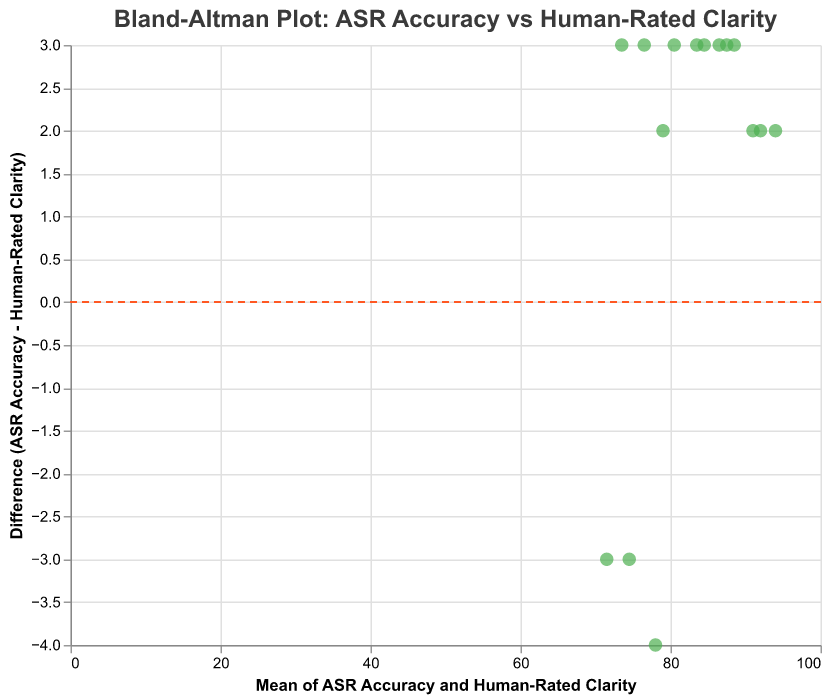What is the title of the plot? The title is typically located at the top of the plot and provides a concise description of what the figure represents. In this case, it gives an overview of the data being compared and the context.
Answer: Bland-Altman Plot: ASR Accuracy vs Human-Rated Clarity How many data points are plotted in the graph? The total number of data points can be counted by identifying each individual point on the plot. Each point corresponds to a specific app in the dataset.
Answer: 15 What does the horizontal axis represent? The horizontal axis is labeled with its respective description. It typically represents one of the variables being compared or a transformation of those variables. In this case, it shows the mean of ASR Accuracy and Human-Rated Clarity.
Answer: Mean of ASR Accuracy and Human-Rated Clarity What does the vertical axis represent? The vertical axis is labeled with its respective description. It typically represents the other variable being compared or a transformation of those variables. In this case, it shows the difference between ASR Accuracy and Human-Rated Clarity.
Answer: Difference (ASR Accuracy - Human-Rated Clarity) Which app shows the largest positive difference between ASR Accuracy and Human-Rated Clarity? The largest positive difference is identified by finding the highest data point above the horizontal dashed line (y=0). The tooltip information can be used to match the app name. In this case, "AutiSpeak" has the highest difference value.
Answer: AutiSpeak How does the app ArticuLearn perform in terms of ASR Accuracy and Human-Rated Clarity? By locating the point labeled "ArticuLearn," check its coordinates against the x-axis and y-axis to find the mean and difference values. The tooltip provides exact values.
Answer: Difference = 2, Mean ≈ 94 Which app has the smallest difference? The smallest difference is identified by finding the data point that lies closest to the horizontal dashed line (y=0). The tooltip information helps to match the app name.
Answer: ClearConverse For the app "PhonemePhriends," what are the mean accuracy and the difference? By locating the point labeled "PhonemePhriends," check its coordinates against the x-axis and y-axis to find the mean and difference values. The tooltip provides exact values.
Answer: Mean = 78, Difference = -4 What's the average mean value of ASR Accuracy and Human-Rated Clarity for all apps? To find the average mean value, sum the mean values of all data points and divide by the number of data points. Calculation: (83.5+76.5+91+71.5+86.5+78+94+80.5+88.5+74.5+84.5+79+92+73.5+87.5)/15 ≈ 82.97.
Answer: 82.97 